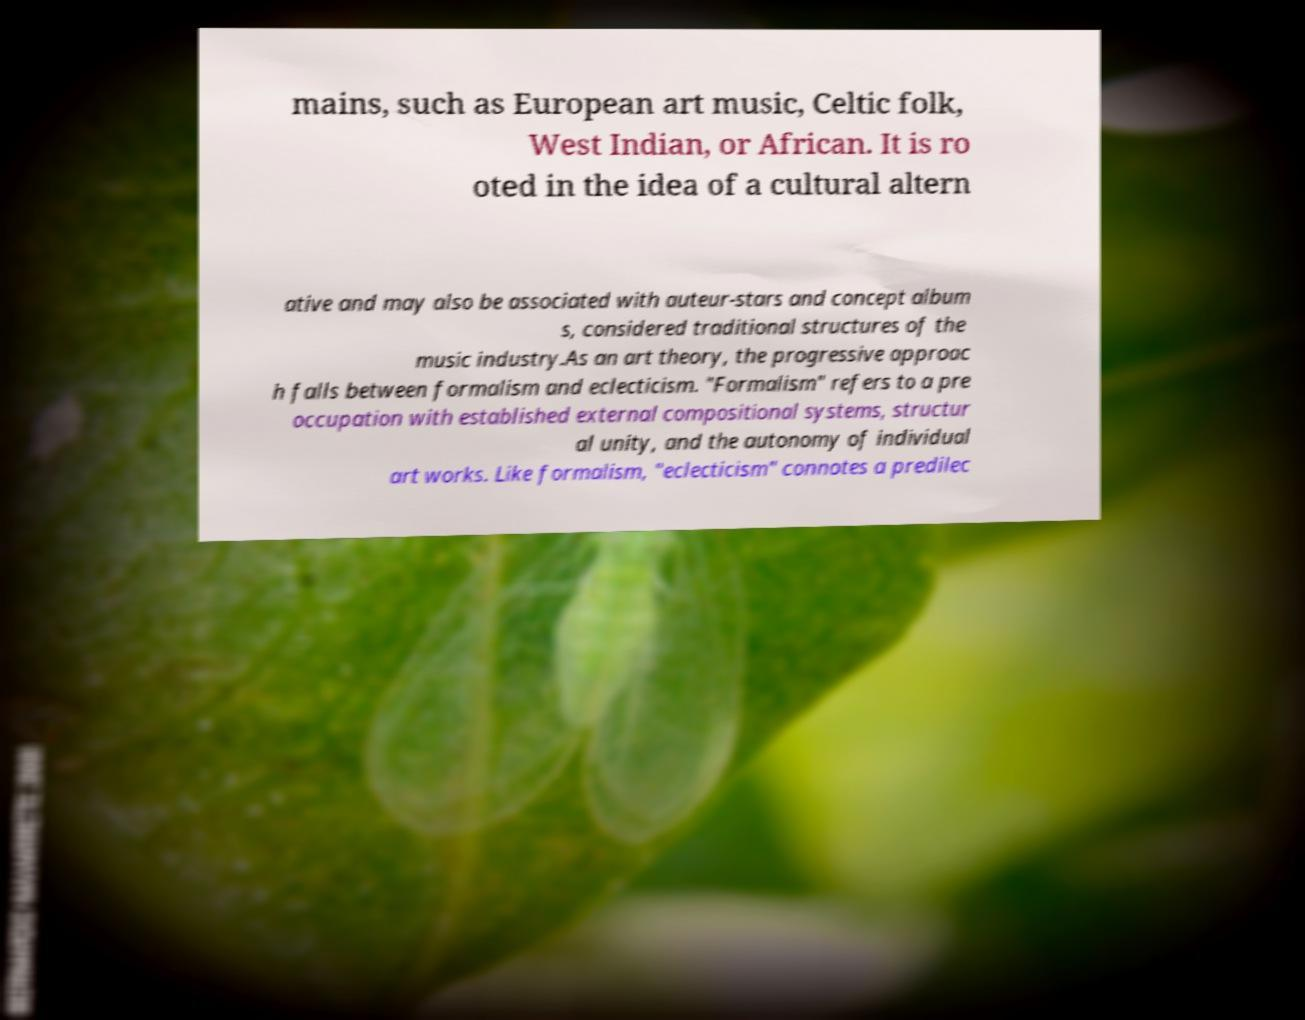What messages or text are displayed in this image? I need them in a readable, typed format. mains, such as European art music, Celtic folk, West Indian, or African. It is ro oted in the idea of a cultural altern ative and may also be associated with auteur-stars and concept album s, considered traditional structures of the music industry.As an art theory, the progressive approac h falls between formalism and eclecticism. "Formalism" refers to a pre occupation with established external compositional systems, structur al unity, and the autonomy of individual art works. Like formalism, "eclecticism" connotes a predilec 